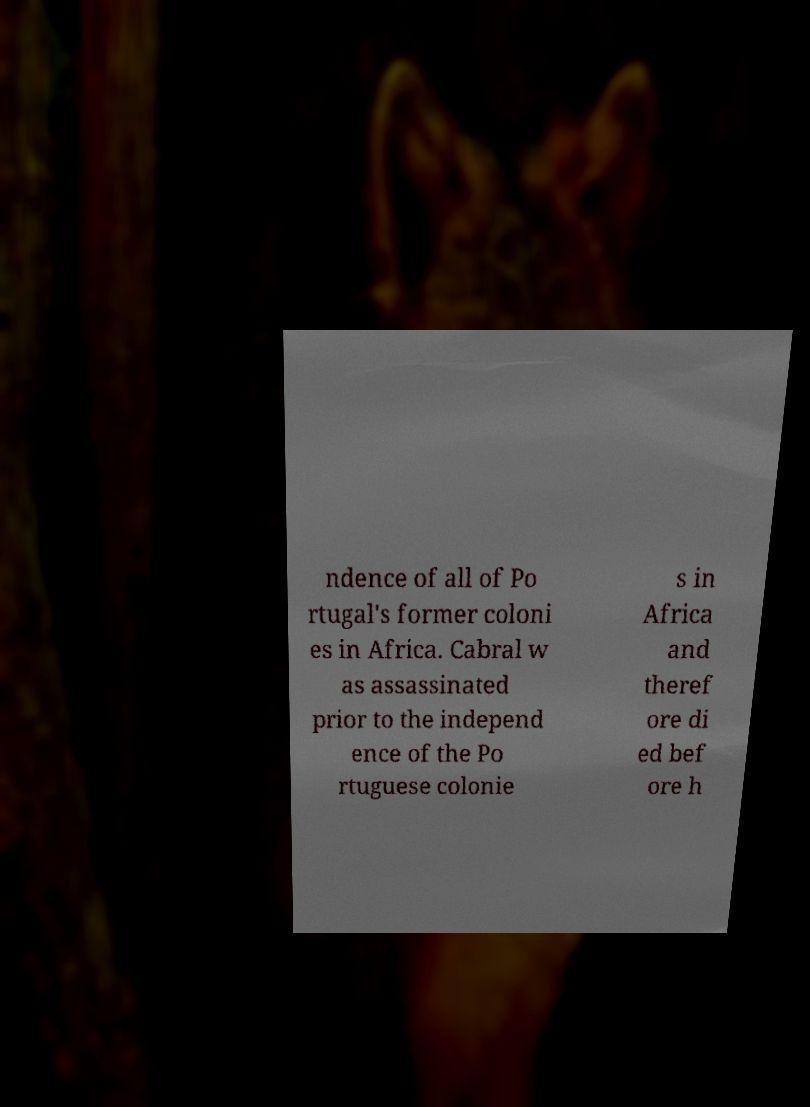I need the written content from this picture converted into text. Can you do that? ndence of all of Po rtugal's former coloni es in Africa. Cabral w as assassinated prior to the independ ence of the Po rtuguese colonie s in Africa and theref ore di ed bef ore h 